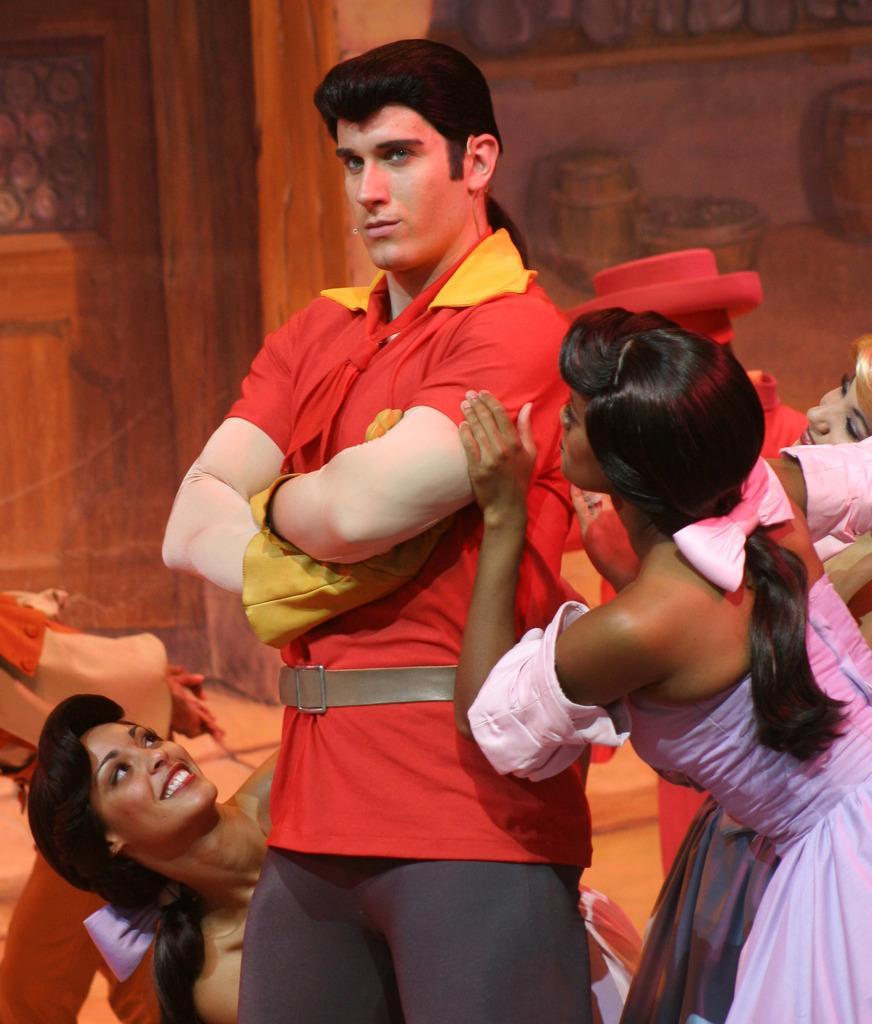Could you give a brief overview of what you see in this image? In the picture I can see a man in the center and he is wearing a red color T-shirt. I can see a woman on the bottom left side and there is a smile on her face. I can see two women on the right side. It is looking like a wooden door on the top left side. I can see the paintings of wooden drums on the wall on the top right side of the picture. 